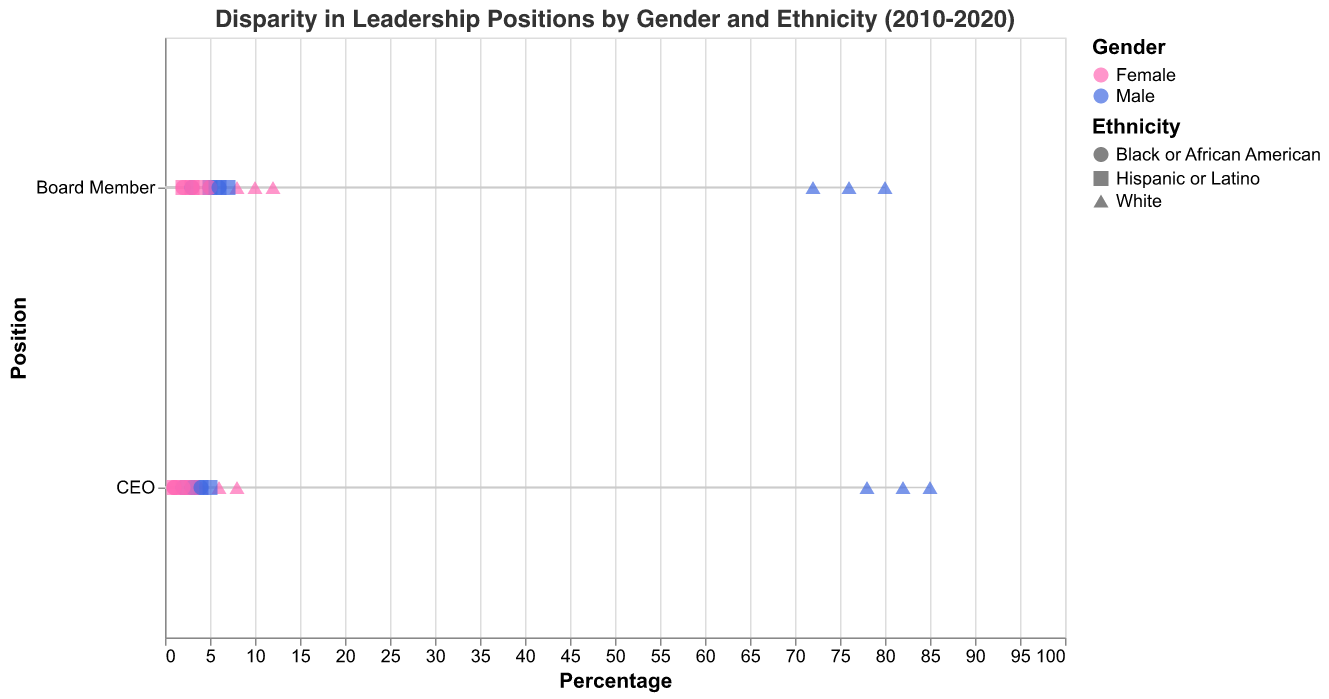What is the title of the figure? The title of the figure is typically displayed at the top and summarizes the content presented. Here, the title is provided within the code.
Answer: Disparity in Leadership Positions by Gender and Ethnicity (2010-2020) How many positions are depicted in the figure? The y-axis of the figure shows the different positions. According to the data, the positions are "CEO" and "Board Member."
Answer: 2 Which gender has a higher percentage for the CEO position across all years? By comparing the percentages for males and females in the CEO position over the years, we observe that males consistently have higher percentages.
Answer: Male What's the change in the percentage of Hispanic or Latino females in Board Member positions from 2010 to 2020? The percentage in 2010 is 2%. In 2020, it is 4%. Calculate the difference: 4% - 2% = 2%.
Answer: 2% Which year showed the highest percentage of Black or African American females in Board Member positions? Examine the percentages for Black or African American females in Board Member positions across all years. The highest percentage, 5%, is in 2020.
Answer: 2020 In 2020, how many more White males were CEOs compared to White females? In 2020, 78% of CEOs were White males, and 8% were White females. The difference is 78% - 8% = 70%.
Answer: 70% How did the percentage of Black or African American males in CEO positions change from 2010 to 2020? The percentage in 2010 is 2%. In 2020, it is 4%. Calculate the difference: 4% - 2% = 2%.
Answer: 2% Compare the representation of females and males across all ethnicities in Board Member positions in 2015. Which gender has a higher average percentage? Summarize the percentages for females (10%+3%+3%=16%) and males (76%+5%+6%=87%) and find the averages: 16%/3 = 5.33% for females, and 87%/3 = 29% for males.
Answer: Males Across the decade, did the representation of White females as CEOs increase, decrease, or remain the same? Analyze the data points for White females in CEO positions: 4% in 2010, 6% in 2015, and 8% in 2020. The representation increased over the years.
Answer: Increase In which year did Hispanic or Latino males have the highest percentage in Board Member positions? Compare the percentages of Hispanic or Latino males in Board Member positions for each year: 5% in 2010, 6% in 2015, and 7% in 2020. The highest is 7% in 2020.
Answer: 2020 